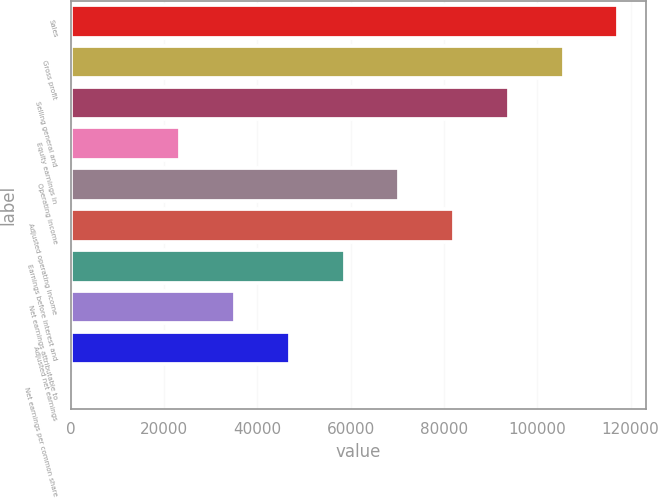<chart> <loc_0><loc_0><loc_500><loc_500><bar_chart><fcel>Sales<fcel>Gross profit<fcel>Selling general and<fcel>Equity earnings in<fcel>Operating income<fcel>Adjusted operating income<fcel>Earnings before interest and<fcel>Net earnings attributable to<fcel>Adjusted net earnings<fcel>Net earnings per common share<nl><fcel>117351<fcel>105616<fcel>93881.6<fcel>23473.3<fcel>70412.1<fcel>82146.9<fcel>58677.4<fcel>35208<fcel>46942.7<fcel>3.82<nl></chart> 